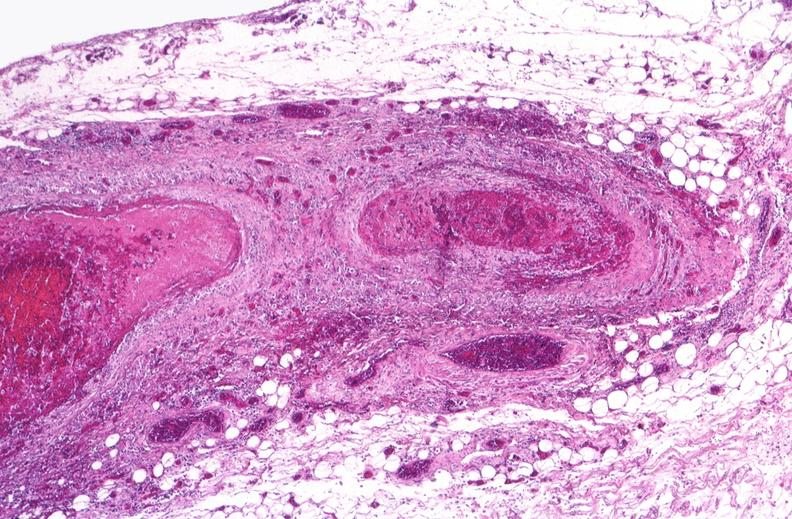s muscle atrophy present?
Answer the question using a single word or phrase. No 